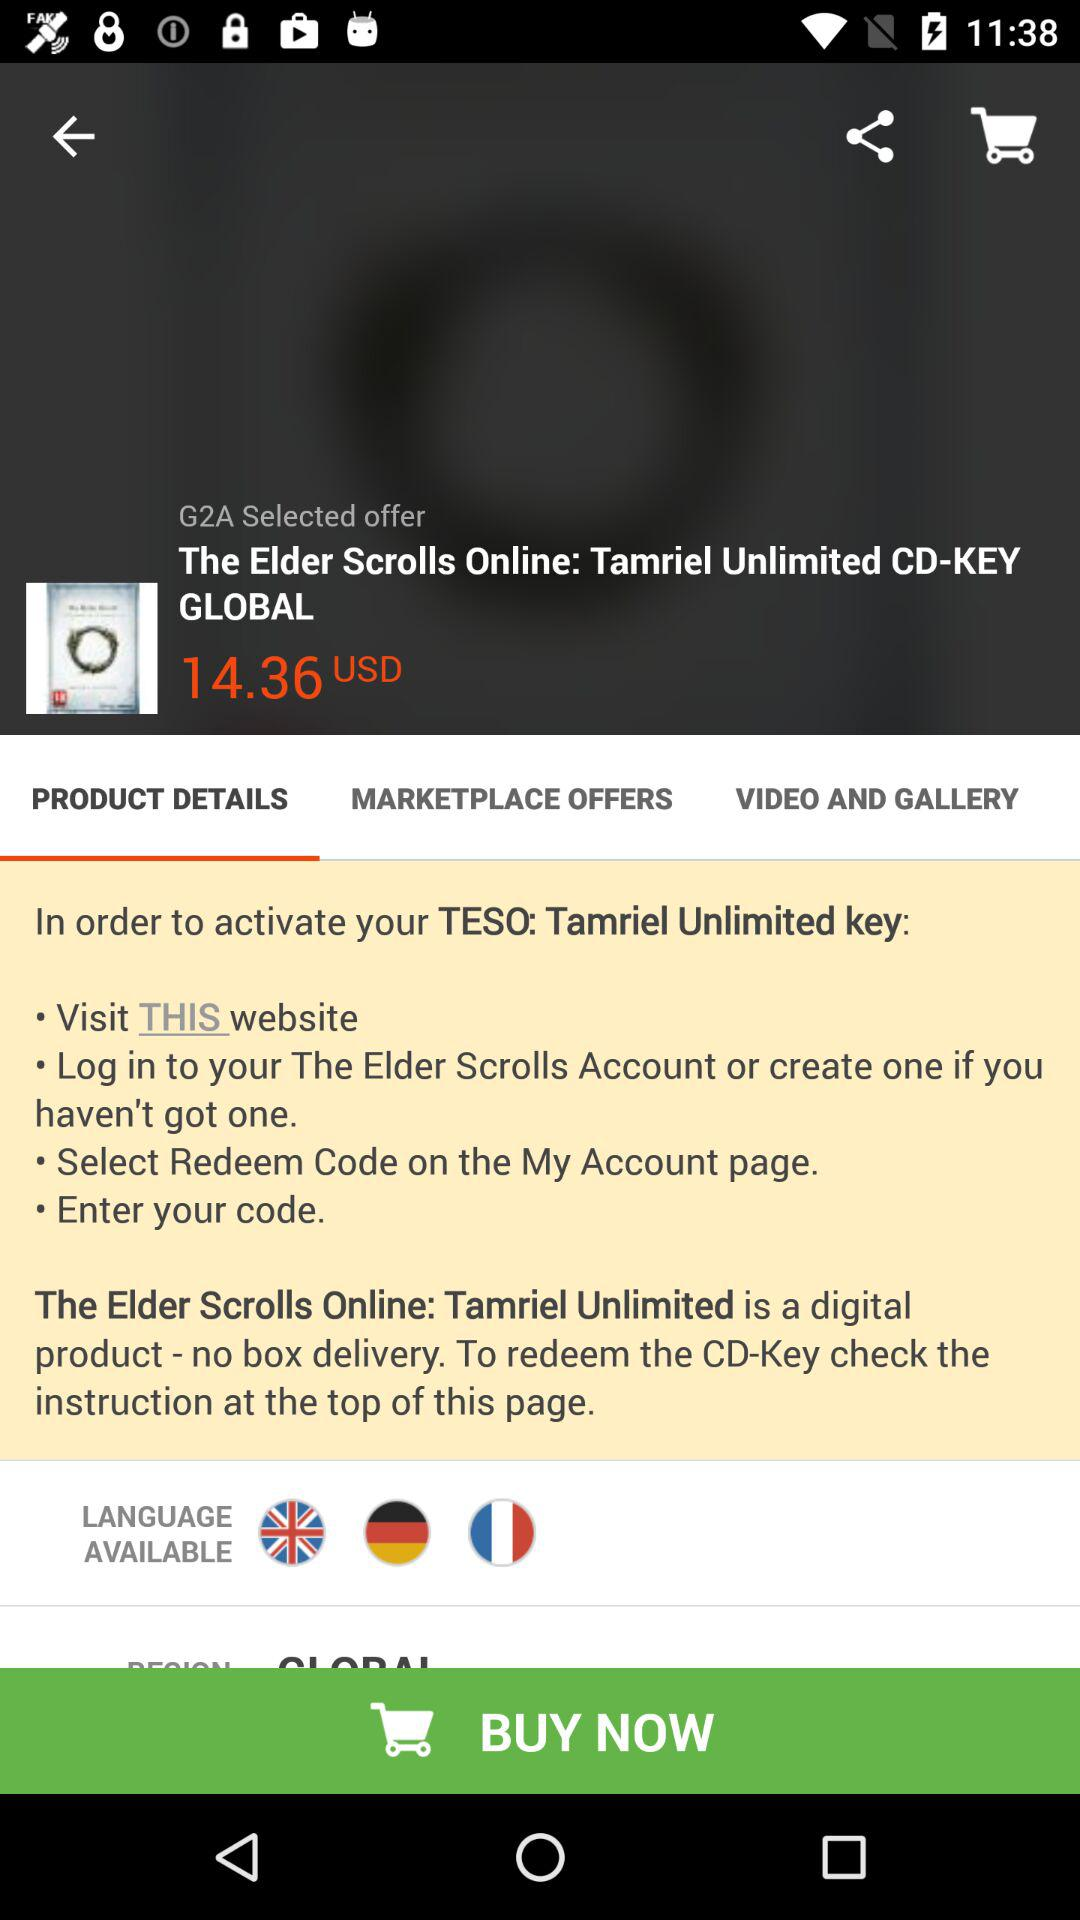How many languages are available for this product?
Answer the question using a single word or phrase. 3 